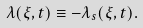Convert formula to latex. <formula><loc_0><loc_0><loc_500><loc_500>\lambda ( \xi , t ) \equiv - \lambda _ { s } ( \xi , t ) .</formula> 